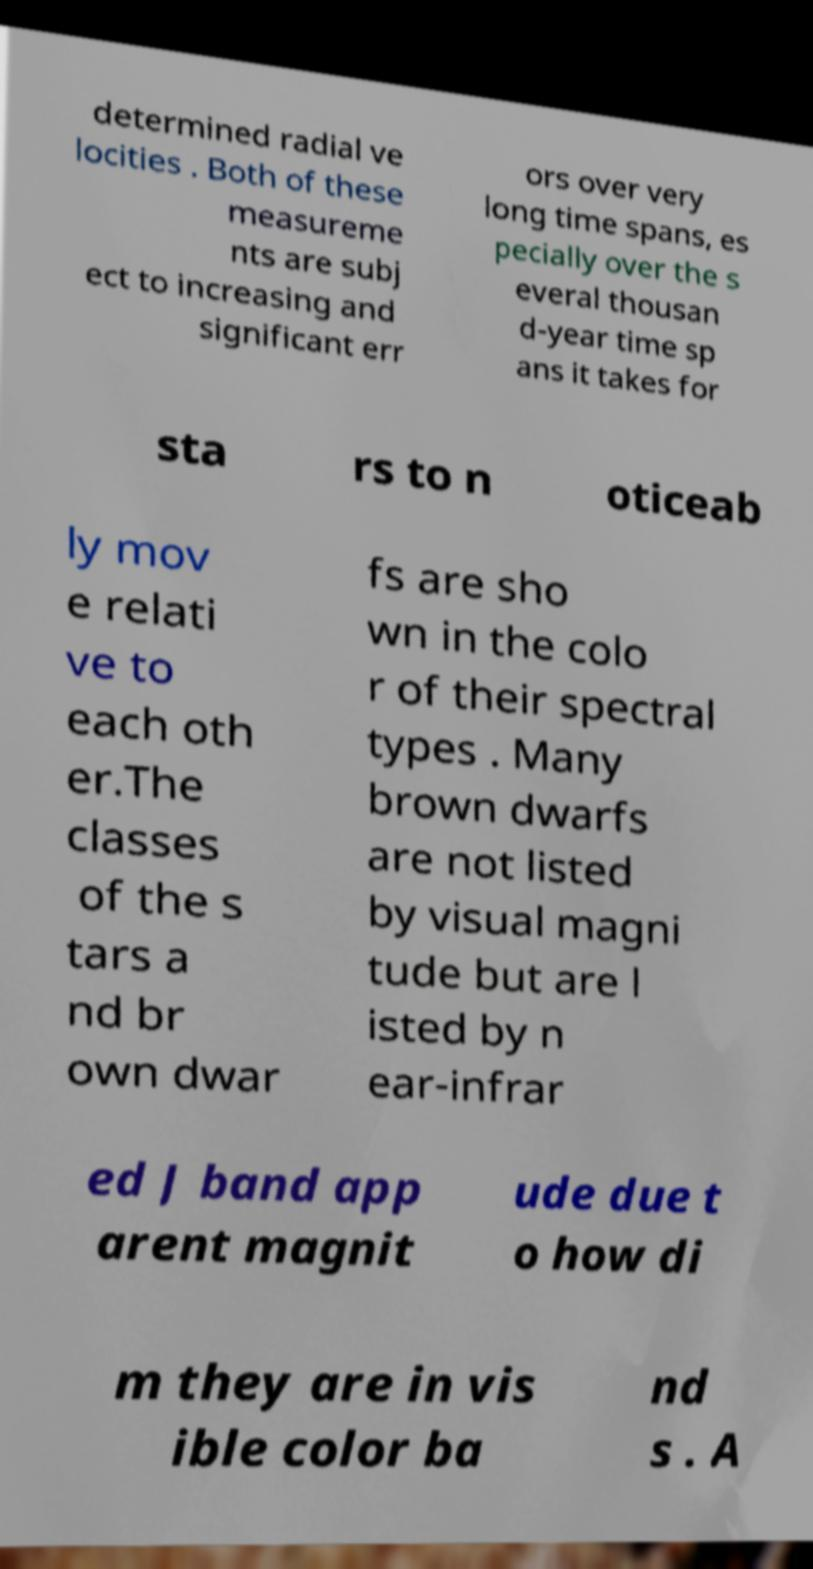What messages or text are displayed in this image? I need them in a readable, typed format. determined radial ve locities . Both of these measureme nts are subj ect to increasing and significant err ors over very long time spans, es pecially over the s everal thousan d-year time sp ans it takes for sta rs to n oticeab ly mov e relati ve to each oth er.The classes of the s tars a nd br own dwar fs are sho wn in the colo r of their spectral types . Many brown dwarfs are not listed by visual magni tude but are l isted by n ear-infrar ed J band app arent magnit ude due t o how di m they are in vis ible color ba nd s . A 